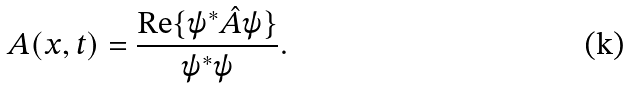<formula> <loc_0><loc_0><loc_500><loc_500>A ( { x } , t ) = \frac { \text {Re} \{ \psi ^ { * } \hat { A } \psi \} } { \psi ^ { * } \psi } .</formula> 